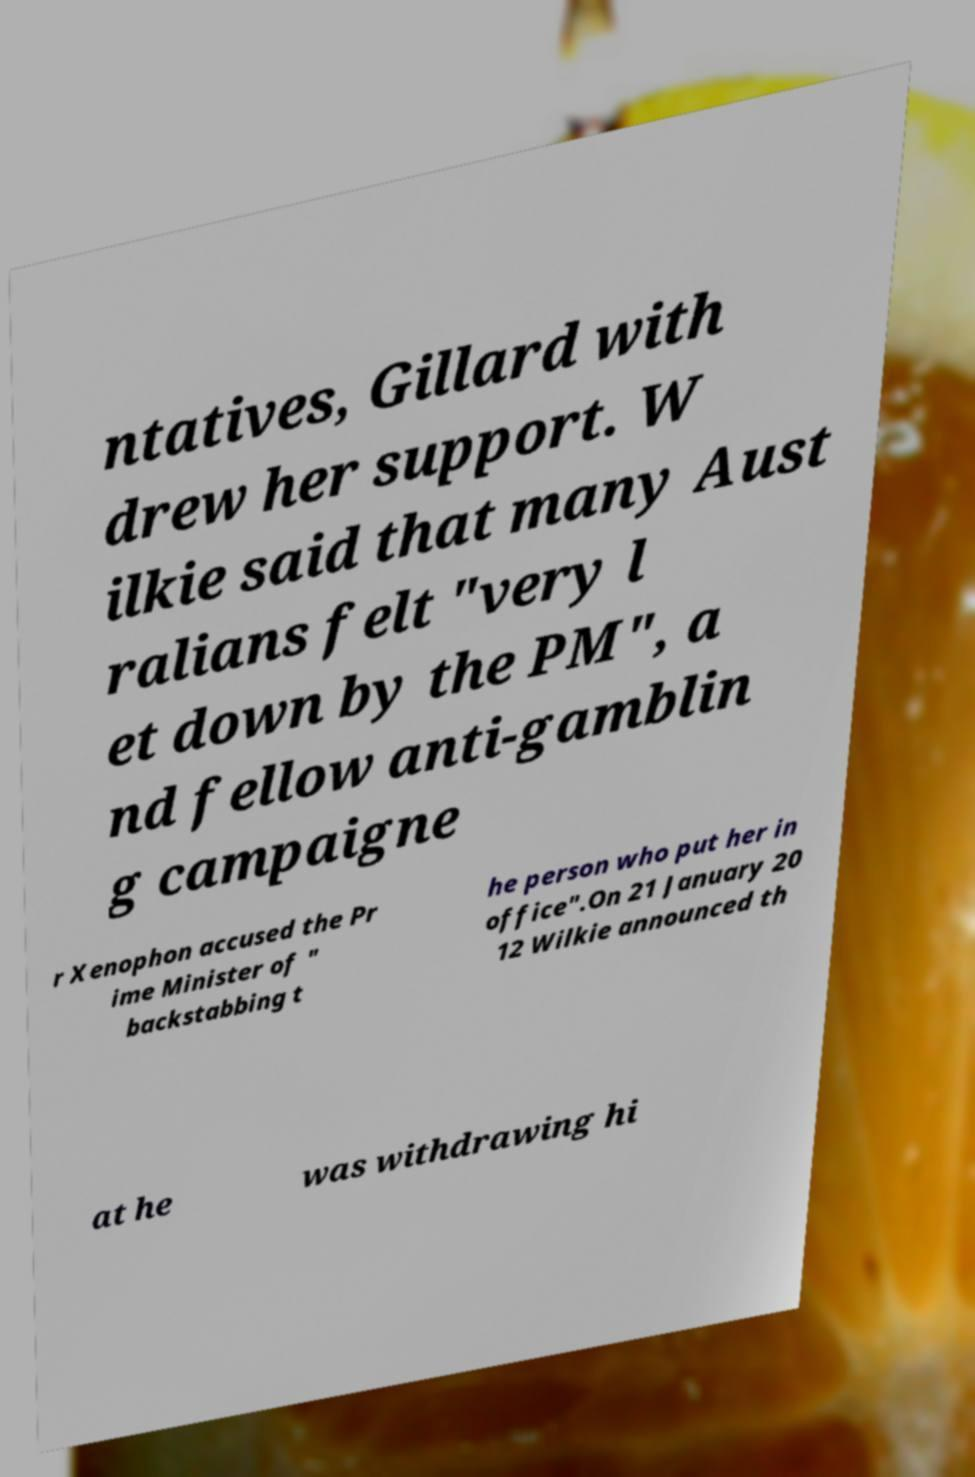For documentation purposes, I need the text within this image transcribed. Could you provide that? ntatives, Gillard with drew her support. W ilkie said that many Aust ralians felt "very l et down by the PM", a nd fellow anti-gamblin g campaigne r Xenophon accused the Pr ime Minister of " backstabbing t he person who put her in office".On 21 January 20 12 Wilkie announced th at he was withdrawing hi 